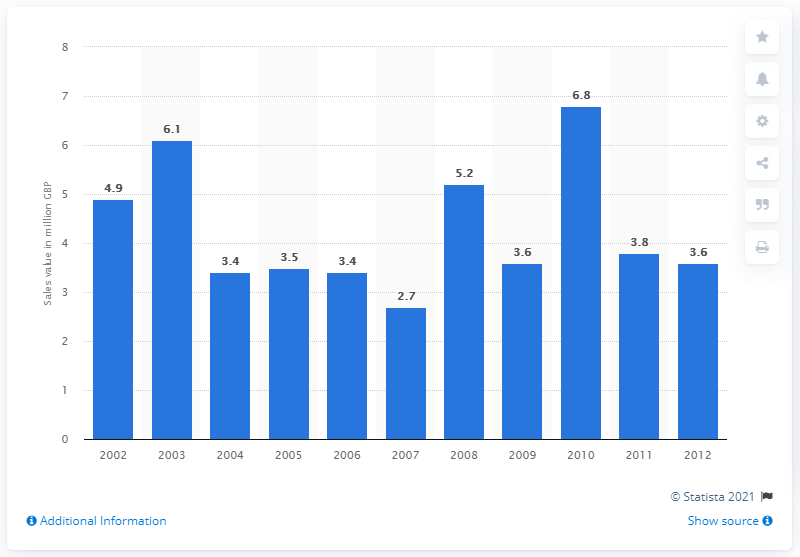Specify some key components in this picture. In 2010, the retail value of fairtrade honey products was estimated to be approximately 6.8 million. 